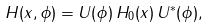Convert formula to latex. <formula><loc_0><loc_0><loc_500><loc_500>H ( x , \phi ) = U ( \phi ) \, H _ { 0 } ( x ) \, U ^ { * } ( \phi ) ,</formula> 